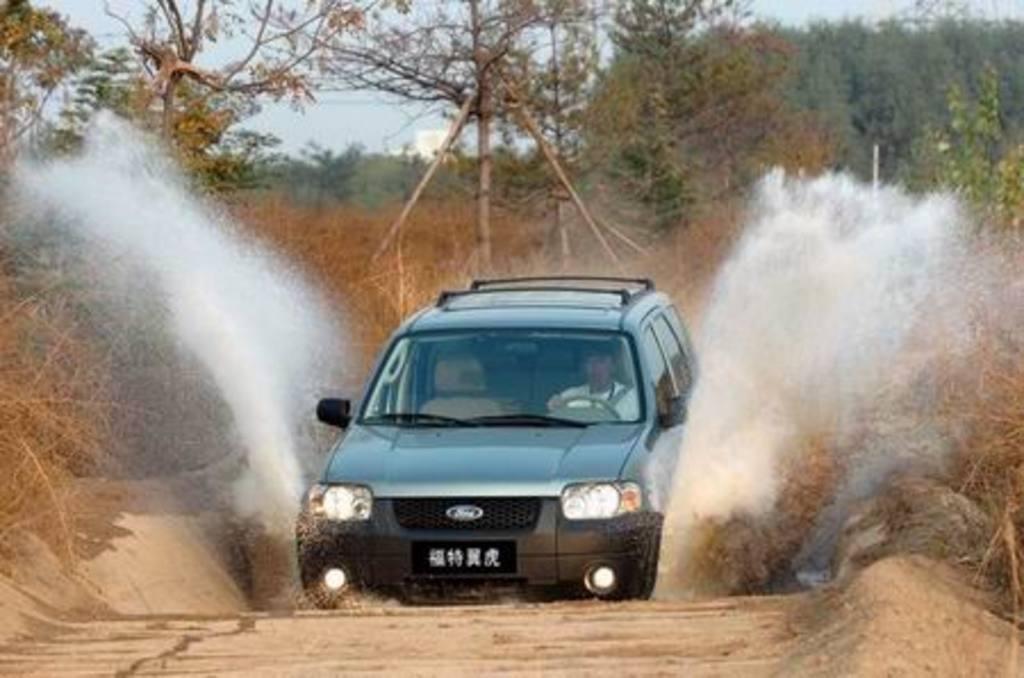In one or two sentences, can you explain what this image depicts? In the picture I can see a car in which a person is sitting is moving on the road and here I can see the water coming out, I can see dry plants, trees and the sky in the background. 